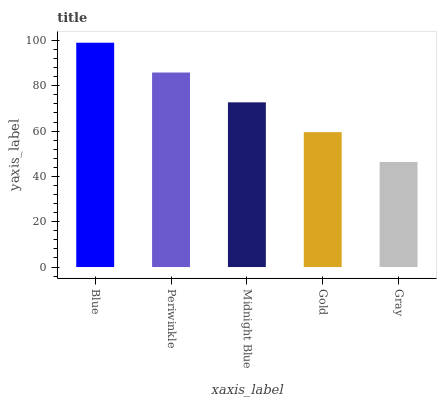Is Gray the minimum?
Answer yes or no. Yes. Is Blue the maximum?
Answer yes or no. Yes. Is Periwinkle the minimum?
Answer yes or no. No. Is Periwinkle the maximum?
Answer yes or no. No. Is Blue greater than Periwinkle?
Answer yes or no. Yes. Is Periwinkle less than Blue?
Answer yes or no. Yes. Is Periwinkle greater than Blue?
Answer yes or no. No. Is Blue less than Periwinkle?
Answer yes or no. No. Is Midnight Blue the high median?
Answer yes or no. Yes. Is Midnight Blue the low median?
Answer yes or no. Yes. Is Periwinkle the high median?
Answer yes or no. No. Is Gray the low median?
Answer yes or no. No. 